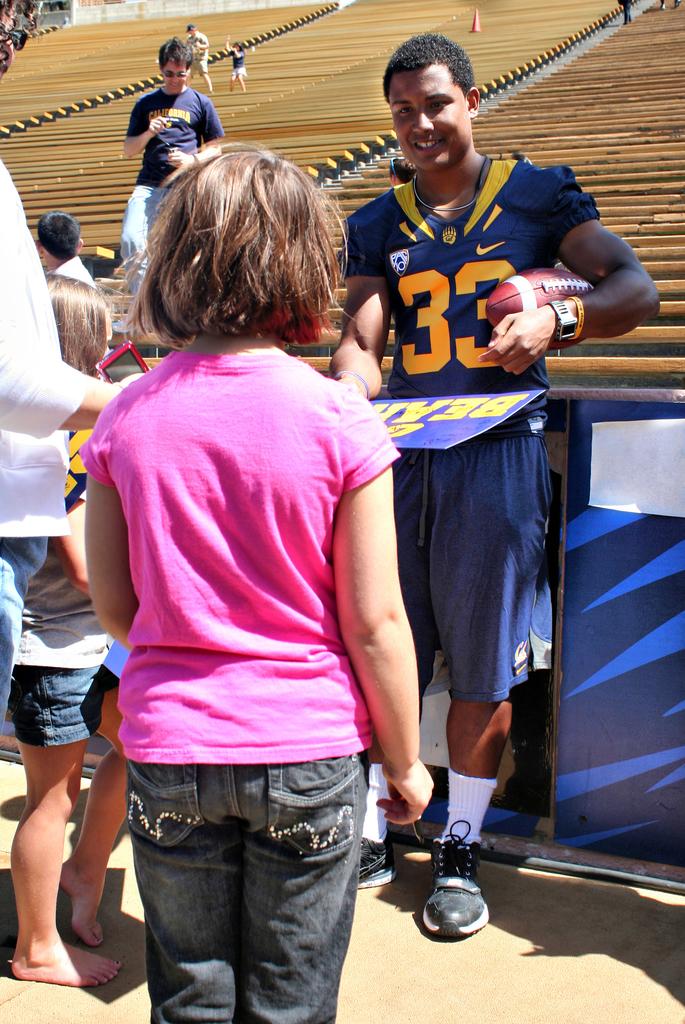What number is the player?
Give a very brief answer. 33. Is the child in the front in a pink shirt?
Your response must be concise. Answering does not require reading text in the image. 